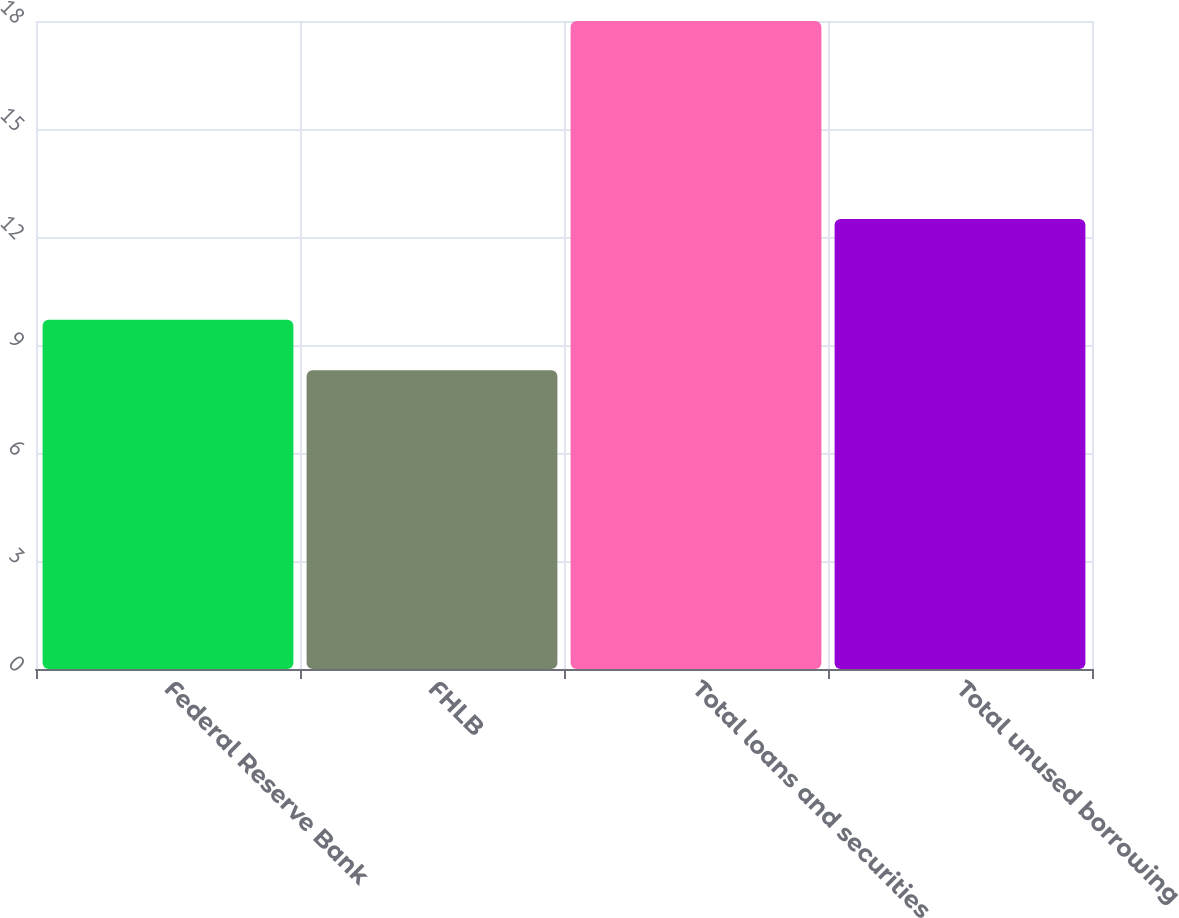<chart> <loc_0><loc_0><loc_500><loc_500><bar_chart><fcel>Federal Reserve Bank<fcel>FHLB<fcel>Total loans and securities<fcel>Total unused borrowing<nl><fcel>9.7<fcel>8.3<fcel>18<fcel>12.5<nl></chart> 